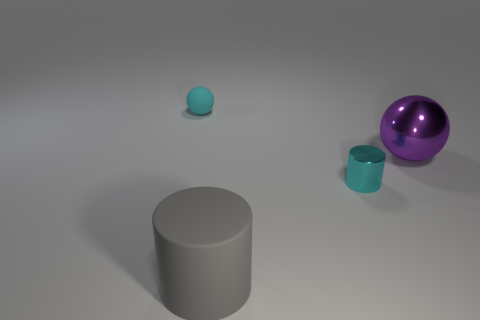Can you describe the lighting and shadows in the scene? The lighting appears to be coming from above, creating soft shadows that stretch away from the objects. This suggests a single diffuse light source, giving the scene a calm and even tone. 